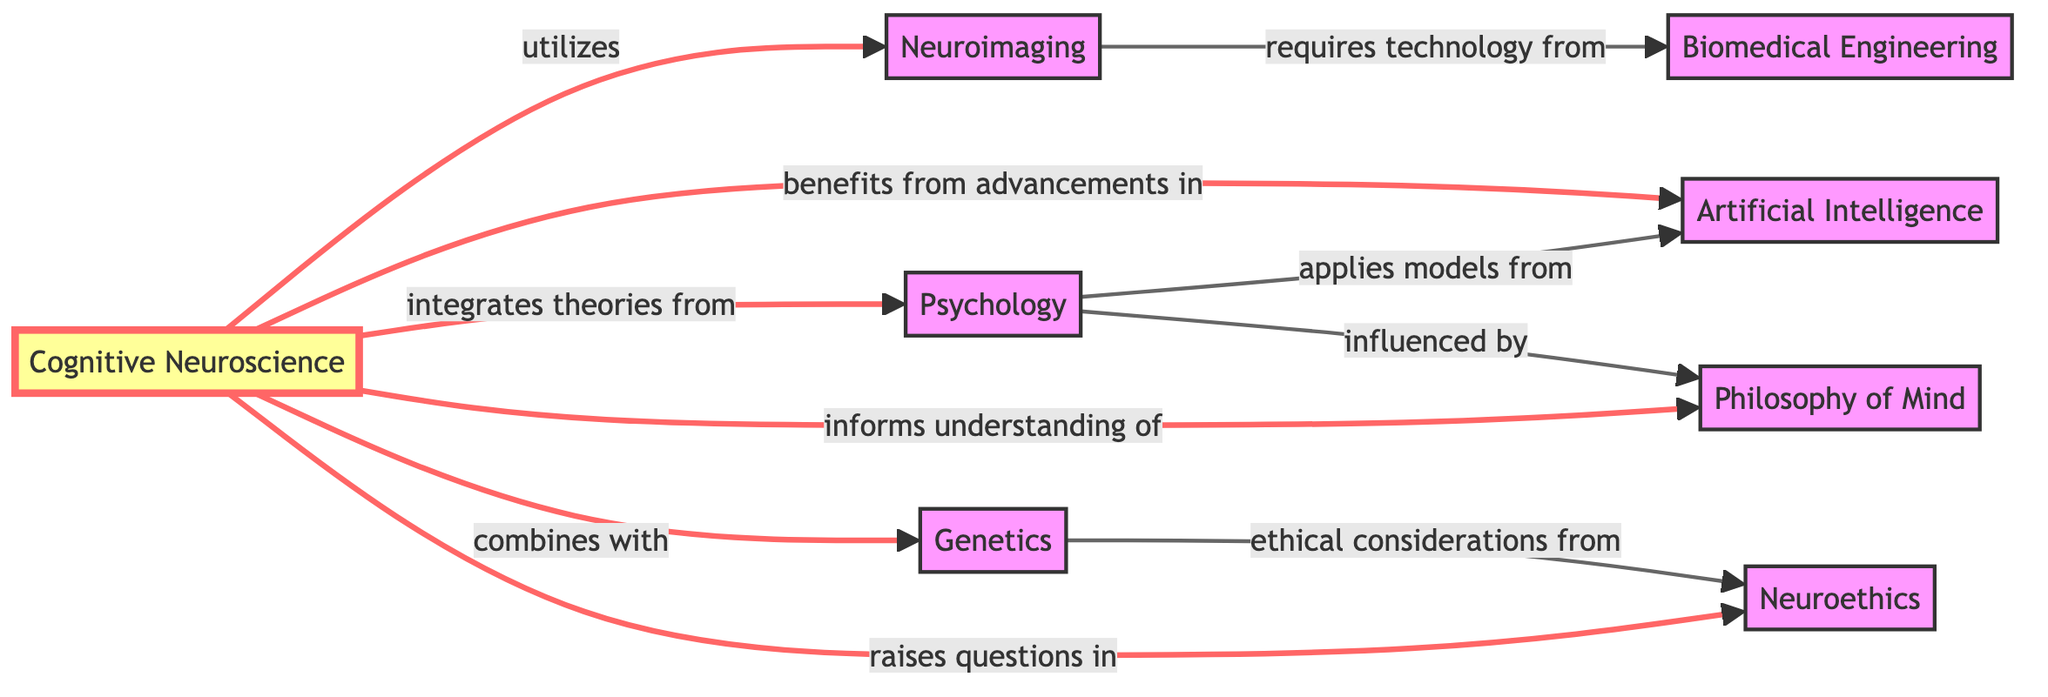What is the central node of the diagram? The central node of the diagram is "Cognitive Neuroscience," which is represented at the center and connected to multiple other nodes.
Answer: Cognitive Neuroscience How many nodes are present in the diagram? There are a total of eight nodes in the diagram, as listed under the "nodes" section of the data.
Answer: 8 Which node is connected to "Psychology" indicating influence? The node connected to "Psychology" indicating influence is "Philosophy of Mind," as denoted by the edge labeled "influenced by."
Answer: Philosophy of Mind What relationship exists between "Cognitive Neuroscience" and "Artificial Intelligence"? The relationship between "Cognitive Neuroscience" and "Artificial Intelligence" is that "Cognitive Neuroscience" benefits from advancements in "Artificial Intelligence," as indicated by the labeled edge.
Answer: benefits from advancements in Which node connects to "Neuroimaging"? The node that connects to "Neuroimaging" is "Cognitive Neuroscience," as shown by the edge labeled "utilizes."
Answer: Cognitive Neuroscience How many edges are present in the diagram? There are ten edges in the diagram, which represent the various relationships between the nodes.
Answer: 10 What ethical concern is associated with "Genetics"? The ethical concern associated with "Genetics" is linked to "Neuroethics," specifically around "ethical considerations from," as noted in the diagram.
Answer: ethical considerations from What type of relationship does "Neuroimaging" have with "Biomedical Engineering"? "Neuroimaging" has a relationship of requiring technology from "Biomedical Engineering," as indicated by the edge connecting them.
Answer: requires technology from List all nodes that connect directly to "Cognitive Neuroscience". The nodes that connect directly to "Cognitive Neuroscience" are "Neuroimaging," "Psychology," "Artificial Intelligence," "Genetics," "Philosophy of Mind," and "Neuroethics." This indicates the various fields that intersect with Cognitive Neuroscience.
Answer: Neuroimaging, Psychology, Artificial Intelligence, Genetics, Philosophy of Mind, Neuroethics 